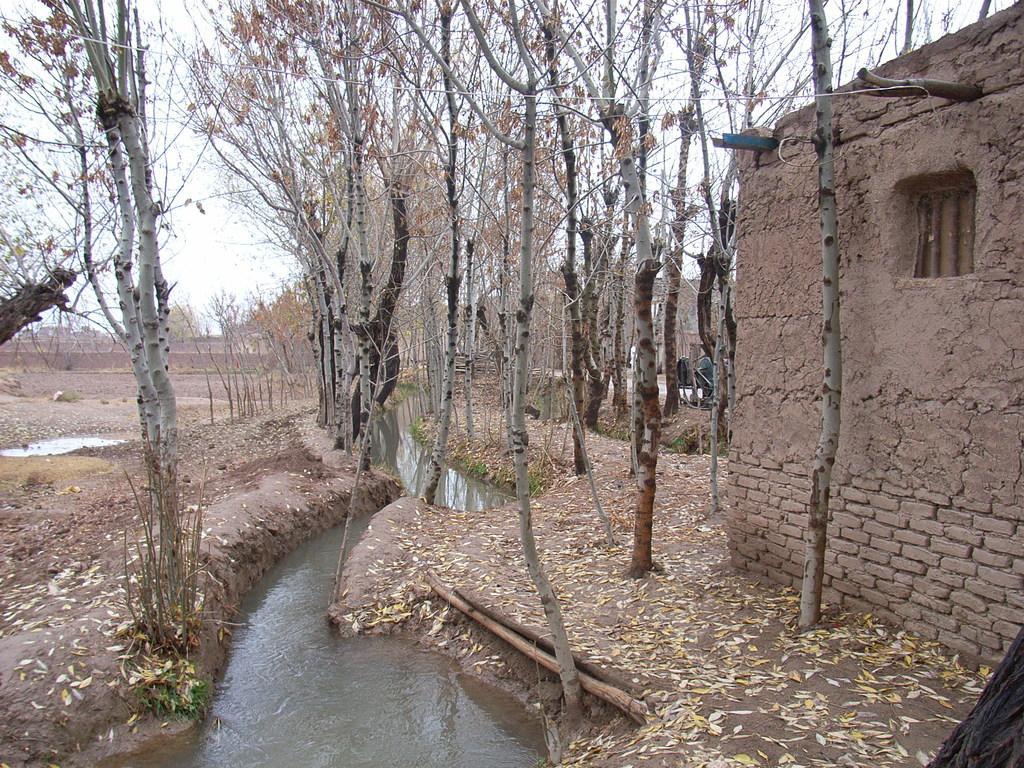Can you describe this image briefly? In this image we can see the brick house and also trees and water. We can also see the dried leaves on the land. Sky is also visible. 